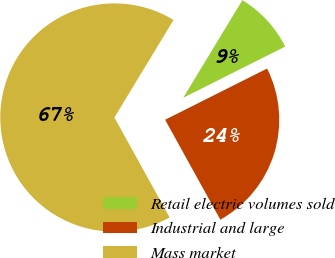Convert chart to OTSL. <chart><loc_0><loc_0><loc_500><loc_500><pie_chart><fcel>Retail electric volumes sold<fcel>Industrial and large<fcel>Mass market<nl><fcel>8.92%<fcel>24.37%<fcel>66.71%<nl></chart> 